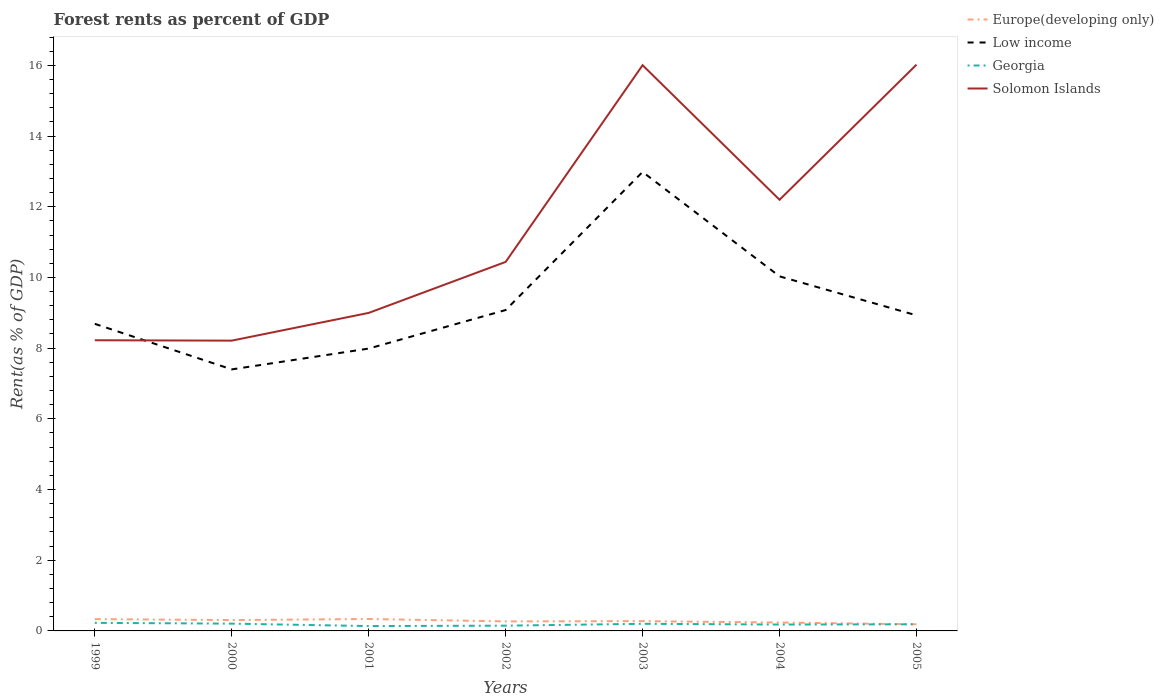How many different coloured lines are there?
Your answer should be very brief. 4. Is the number of lines equal to the number of legend labels?
Offer a terse response. Yes. Across all years, what is the maximum forest rent in Solomon Islands?
Keep it short and to the point. 8.21. What is the total forest rent in Low income in the graph?
Offer a terse response. 2.95. What is the difference between the highest and the second highest forest rent in Solomon Islands?
Offer a terse response. 7.81. How many lines are there?
Provide a succinct answer. 4. What is the difference between two consecutive major ticks on the Y-axis?
Provide a short and direct response. 2. Does the graph contain grids?
Give a very brief answer. No. Where does the legend appear in the graph?
Make the answer very short. Top right. How many legend labels are there?
Provide a succinct answer. 4. What is the title of the graph?
Provide a short and direct response. Forest rents as percent of GDP. What is the label or title of the Y-axis?
Your answer should be compact. Rent(as % of GDP). What is the Rent(as % of GDP) in Europe(developing only) in 1999?
Keep it short and to the point. 0.33. What is the Rent(as % of GDP) in Low income in 1999?
Provide a succinct answer. 8.69. What is the Rent(as % of GDP) in Georgia in 1999?
Your answer should be compact. 0.23. What is the Rent(as % of GDP) of Solomon Islands in 1999?
Give a very brief answer. 8.22. What is the Rent(as % of GDP) in Europe(developing only) in 2000?
Offer a very short reply. 0.31. What is the Rent(as % of GDP) in Low income in 2000?
Offer a terse response. 7.4. What is the Rent(as % of GDP) of Georgia in 2000?
Ensure brevity in your answer.  0.21. What is the Rent(as % of GDP) in Solomon Islands in 2000?
Keep it short and to the point. 8.21. What is the Rent(as % of GDP) in Europe(developing only) in 2001?
Keep it short and to the point. 0.34. What is the Rent(as % of GDP) of Low income in 2001?
Your answer should be compact. 7.99. What is the Rent(as % of GDP) in Georgia in 2001?
Make the answer very short. 0.14. What is the Rent(as % of GDP) of Solomon Islands in 2001?
Your answer should be compact. 9. What is the Rent(as % of GDP) of Europe(developing only) in 2002?
Provide a short and direct response. 0.27. What is the Rent(as % of GDP) of Low income in 2002?
Offer a terse response. 9.08. What is the Rent(as % of GDP) of Georgia in 2002?
Provide a short and direct response. 0.15. What is the Rent(as % of GDP) of Solomon Islands in 2002?
Your answer should be very brief. 10.44. What is the Rent(as % of GDP) in Europe(developing only) in 2003?
Give a very brief answer. 0.28. What is the Rent(as % of GDP) in Low income in 2003?
Offer a very short reply. 12.98. What is the Rent(as % of GDP) of Georgia in 2003?
Offer a very short reply. 0.2. What is the Rent(as % of GDP) of Solomon Islands in 2003?
Your response must be concise. 16. What is the Rent(as % of GDP) in Europe(developing only) in 2004?
Ensure brevity in your answer.  0.24. What is the Rent(as % of GDP) of Low income in 2004?
Keep it short and to the point. 10.03. What is the Rent(as % of GDP) of Georgia in 2004?
Your answer should be very brief. 0.18. What is the Rent(as % of GDP) in Solomon Islands in 2004?
Offer a terse response. 12.2. What is the Rent(as % of GDP) in Europe(developing only) in 2005?
Provide a succinct answer. 0.19. What is the Rent(as % of GDP) in Low income in 2005?
Provide a succinct answer. 8.93. What is the Rent(as % of GDP) of Georgia in 2005?
Your answer should be very brief. 0.19. What is the Rent(as % of GDP) in Solomon Islands in 2005?
Provide a short and direct response. 16.02. Across all years, what is the maximum Rent(as % of GDP) of Europe(developing only)?
Your response must be concise. 0.34. Across all years, what is the maximum Rent(as % of GDP) of Low income?
Give a very brief answer. 12.98. Across all years, what is the maximum Rent(as % of GDP) of Georgia?
Your response must be concise. 0.23. Across all years, what is the maximum Rent(as % of GDP) in Solomon Islands?
Your answer should be compact. 16.02. Across all years, what is the minimum Rent(as % of GDP) of Europe(developing only)?
Your answer should be very brief. 0.19. Across all years, what is the minimum Rent(as % of GDP) in Low income?
Provide a succinct answer. 7.4. Across all years, what is the minimum Rent(as % of GDP) in Georgia?
Offer a terse response. 0.14. Across all years, what is the minimum Rent(as % of GDP) in Solomon Islands?
Your answer should be compact. 8.21. What is the total Rent(as % of GDP) in Europe(developing only) in the graph?
Give a very brief answer. 1.95. What is the total Rent(as % of GDP) in Low income in the graph?
Your answer should be compact. 65.1. What is the total Rent(as % of GDP) in Georgia in the graph?
Ensure brevity in your answer.  1.29. What is the total Rent(as % of GDP) of Solomon Islands in the graph?
Provide a short and direct response. 80.09. What is the difference between the Rent(as % of GDP) in Europe(developing only) in 1999 and that in 2000?
Your response must be concise. 0.03. What is the difference between the Rent(as % of GDP) of Low income in 1999 and that in 2000?
Your answer should be very brief. 1.29. What is the difference between the Rent(as % of GDP) of Georgia in 1999 and that in 2000?
Ensure brevity in your answer.  0.02. What is the difference between the Rent(as % of GDP) in Solomon Islands in 1999 and that in 2000?
Your response must be concise. 0.01. What is the difference between the Rent(as % of GDP) of Europe(developing only) in 1999 and that in 2001?
Provide a succinct answer. -0. What is the difference between the Rent(as % of GDP) in Low income in 1999 and that in 2001?
Provide a short and direct response. 0.7. What is the difference between the Rent(as % of GDP) in Georgia in 1999 and that in 2001?
Ensure brevity in your answer.  0.09. What is the difference between the Rent(as % of GDP) in Solomon Islands in 1999 and that in 2001?
Provide a short and direct response. -0.77. What is the difference between the Rent(as % of GDP) of Europe(developing only) in 1999 and that in 2002?
Provide a succinct answer. 0.06. What is the difference between the Rent(as % of GDP) of Low income in 1999 and that in 2002?
Ensure brevity in your answer.  -0.39. What is the difference between the Rent(as % of GDP) of Georgia in 1999 and that in 2002?
Make the answer very short. 0.08. What is the difference between the Rent(as % of GDP) in Solomon Islands in 1999 and that in 2002?
Ensure brevity in your answer.  -2.22. What is the difference between the Rent(as % of GDP) of Europe(developing only) in 1999 and that in 2003?
Your response must be concise. 0.06. What is the difference between the Rent(as % of GDP) of Low income in 1999 and that in 2003?
Provide a succinct answer. -4.3. What is the difference between the Rent(as % of GDP) of Georgia in 1999 and that in 2003?
Offer a very short reply. 0.03. What is the difference between the Rent(as % of GDP) in Solomon Islands in 1999 and that in 2003?
Your answer should be very brief. -7.78. What is the difference between the Rent(as % of GDP) in Europe(developing only) in 1999 and that in 2004?
Make the answer very short. 0.1. What is the difference between the Rent(as % of GDP) in Low income in 1999 and that in 2004?
Offer a terse response. -1.34. What is the difference between the Rent(as % of GDP) of Georgia in 1999 and that in 2004?
Provide a short and direct response. 0.05. What is the difference between the Rent(as % of GDP) of Solomon Islands in 1999 and that in 2004?
Offer a terse response. -3.97. What is the difference between the Rent(as % of GDP) of Europe(developing only) in 1999 and that in 2005?
Your response must be concise. 0.15. What is the difference between the Rent(as % of GDP) in Low income in 1999 and that in 2005?
Give a very brief answer. -0.24. What is the difference between the Rent(as % of GDP) in Georgia in 1999 and that in 2005?
Offer a terse response. 0.04. What is the difference between the Rent(as % of GDP) of Solomon Islands in 1999 and that in 2005?
Offer a terse response. -7.8. What is the difference between the Rent(as % of GDP) of Europe(developing only) in 2000 and that in 2001?
Your answer should be compact. -0.03. What is the difference between the Rent(as % of GDP) of Low income in 2000 and that in 2001?
Your answer should be compact. -0.59. What is the difference between the Rent(as % of GDP) in Georgia in 2000 and that in 2001?
Offer a terse response. 0.07. What is the difference between the Rent(as % of GDP) in Solomon Islands in 2000 and that in 2001?
Keep it short and to the point. -0.78. What is the difference between the Rent(as % of GDP) of Europe(developing only) in 2000 and that in 2002?
Provide a succinct answer. 0.04. What is the difference between the Rent(as % of GDP) in Low income in 2000 and that in 2002?
Offer a very short reply. -1.68. What is the difference between the Rent(as % of GDP) of Georgia in 2000 and that in 2002?
Provide a short and direct response. 0.06. What is the difference between the Rent(as % of GDP) of Solomon Islands in 2000 and that in 2002?
Ensure brevity in your answer.  -2.23. What is the difference between the Rent(as % of GDP) of Europe(developing only) in 2000 and that in 2003?
Ensure brevity in your answer.  0.03. What is the difference between the Rent(as % of GDP) in Low income in 2000 and that in 2003?
Offer a terse response. -5.59. What is the difference between the Rent(as % of GDP) of Georgia in 2000 and that in 2003?
Provide a short and direct response. 0. What is the difference between the Rent(as % of GDP) of Solomon Islands in 2000 and that in 2003?
Your answer should be very brief. -7.79. What is the difference between the Rent(as % of GDP) in Europe(developing only) in 2000 and that in 2004?
Your answer should be very brief. 0.07. What is the difference between the Rent(as % of GDP) in Low income in 2000 and that in 2004?
Make the answer very short. -2.63. What is the difference between the Rent(as % of GDP) in Georgia in 2000 and that in 2004?
Your answer should be compact. 0.03. What is the difference between the Rent(as % of GDP) in Solomon Islands in 2000 and that in 2004?
Make the answer very short. -3.98. What is the difference between the Rent(as % of GDP) in Europe(developing only) in 2000 and that in 2005?
Your answer should be compact. 0.12. What is the difference between the Rent(as % of GDP) of Low income in 2000 and that in 2005?
Offer a terse response. -1.53. What is the difference between the Rent(as % of GDP) in Georgia in 2000 and that in 2005?
Offer a very short reply. 0.02. What is the difference between the Rent(as % of GDP) in Solomon Islands in 2000 and that in 2005?
Make the answer very short. -7.81. What is the difference between the Rent(as % of GDP) of Europe(developing only) in 2001 and that in 2002?
Ensure brevity in your answer.  0.07. What is the difference between the Rent(as % of GDP) of Low income in 2001 and that in 2002?
Your answer should be compact. -1.09. What is the difference between the Rent(as % of GDP) of Georgia in 2001 and that in 2002?
Give a very brief answer. -0.01. What is the difference between the Rent(as % of GDP) of Solomon Islands in 2001 and that in 2002?
Make the answer very short. -1.44. What is the difference between the Rent(as % of GDP) of Europe(developing only) in 2001 and that in 2003?
Ensure brevity in your answer.  0.06. What is the difference between the Rent(as % of GDP) of Low income in 2001 and that in 2003?
Offer a terse response. -5. What is the difference between the Rent(as % of GDP) of Georgia in 2001 and that in 2003?
Your response must be concise. -0.06. What is the difference between the Rent(as % of GDP) of Solomon Islands in 2001 and that in 2003?
Ensure brevity in your answer.  -7.01. What is the difference between the Rent(as % of GDP) in Europe(developing only) in 2001 and that in 2004?
Your response must be concise. 0.1. What is the difference between the Rent(as % of GDP) of Low income in 2001 and that in 2004?
Offer a very short reply. -2.04. What is the difference between the Rent(as % of GDP) in Georgia in 2001 and that in 2004?
Provide a short and direct response. -0.04. What is the difference between the Rent(as % of GDP) in Solomon Islands in 2001 and that in 2004?
Your answer should be very brief. -3.2. What is the difference between the Rent(as % of GDP) in Europe(developing only) in 2001 and that in 2005?
Offer a terse response. 0.15. What is the difference between the Rent(as % of GDP) in Low income in 2001 and that in 2005?
Make the answer very short. -0.94. What is the difference between the Rent(as % of GDP) of Georgia in 2001 and that in 2005?
Your response must be concise. -0.05. What is the difference between the Rent(as % of GDP) of Solomon Islands in 2001 and that in 2005?
Offer a very short reply. -7.02. What is the difference between the Rent(as % of GDP) of Europe(developing only) in 2002 and that in 2003?
Your answer should be compact. -0.01. What is the difference between the Rent(as % of GDP) in Low income in 2002 and that in 2003?
Provide a succinct answer. -3.91. What is the difference between the Rent(as % of GDP) in Georgia in 2002 and that in 2003?
Give a very brief answer. -0.05. What is the difference between the Rent(as % of GDP) in Solomon Islands in 2002 and that in 2003?
Your answer should be very brief. -5.56. What is the difference between the Rent(as % of GDP) of Europe(developing only) in 2002 and that in 2004?
Offer a terse response. 0.03. What is the difference between the Rent(as % of GDP) in Low income in 2002 and that in 2004?
Your answer should be compact. -0.95. What is the difference between the Rent(as % of GDP) in Georgia in 2002 and that in 2004?
Provide a short and direct response. -0.03. What is the difference between the Rent(as % of GDP) of Solomon Islands in 2002 and that in 2004?
Your response must be concise. -1.76. What is the difference between the Rent(as % of GDP) in Europe(developing only) in 2002 and that in 2005?
Your response must be concise. 0.08. What is the difference between the Rent(as % of GDP) in Low income in 2002 and that in 2005?
Provide a succinct answer. 0.15. What is the difference between the Rent(as % of GDP) of Georgia in 2002 and that in 2005?
Give a very brief answer. -0.04. What is the difference between the Rent(as % of GDP) of Solomon Islands in 2002 and that in 2005?
Your response must be concise. -5.58. What is the difference between the Rent(as % of GDP) in Europe(developing only) in 2003 and that in 2004?
Give a very brief answer. 0.04. What is the difference between the Rent(as % of GDP) of Low income in 2003 and that in 2004?
Your response must be concise. 2.95. What is the difference between the Rent(as % of GDP) in Georgia in 2003 and that in 2004?
Provide a succinct answer. 0.02. What is the difference between the Rent(as % of GDP) of Solomon Islands in 2003 and that in 2004?
Your answer should be compact. 3.81. What is the difference between the Rent(as % of GDP) in Europe(developing only) in 2003 and that in 2005?
Offer a very short reply. 0.09. What is the difference between the Rent(as % of GDP) in Low income in 2003 and that in 2005?
Provide a short and direct response. 4.06. What is the difference between the Rent(as % of GDP) in Georgia in 2003 and that in 2005?
Give a very brief answer. 0.01. What is the difference between the Rent(as % of GDP) of Solomon Islands in 2003 and that in 2005?
Make the answer very short. -0.02. What is the difference between the Rent(as % of GDP) of Europe(developing only) in 2004 and that in 2005?
Offer a terse response. 0.05. What is the difference between the Rent(as % of GDP) of Low income in 2004 and that in 2005?
Make the answer very short. 1.1. What is the difference between the Rent(as % of GDP) of Georgia in 2004 and that in 2005?
Provide a short and direct response. -0.01. What is the difference between the Rent(as % of GDP) in Solomon Islands in 2004 and that in 2005?
Make the answer very short. -3.82. What is the difference between the Rent(as % of GDP) of Europe(developing only) in 1999 and the Rent(as % of GDP) of Low income in 2000?
Keep it short and to the point. -7.07. What is the difference between the Rent(as % of GDP) in Europe(developing only) in 1999 and the Rent(as % of GDP) in Georgia in 2000?
Provide a succinct answer. 0.13. What is the difference between the Rent(as % of GDP) in Europe(developing only) in 1999 and the Rent(as % of GDP) in Solomon Islands in 2000?
Offer a terse response. -7.88. What is the difference between the Rent(as % of GDP) in Low income in 1999 and the Rent(as % of GDP) in Georgia in 2000?
Offer a terse response. 8.48. What is the difference between the Rent(as % of GDP) of Low income in 1999 and the Rent(as % of GDP) of Solomon Islands in 2000?
Offer a terse response. 0.48. What is the difference between the Rent(as % of GDP) of Georgia in 1999 and the Rent(as % of GDP) of Solomon Islands in 2000?
Provide a short and direct response. -7.98. What is the difference between the Rent(as % of GDP) in Europe(developing only) in 1999 and the Rent(as % of GDP) in Low income in 2001?
Offer a very short reply. -7.65. What is the difference between the Rent(as % of GDP) of Europe(developing only) in 1999 and the Rent(as % of GDP) of Georgia in 2001?
Offer a very short reply. 0.2. What is the difference between the Rent(as % of GDP) of Europe(developing only) in 1999 and the Rent(as % of GDP) of Solomon Islands in 2001?
Your answer should be very brief. -8.66. What is the difference between the Rent(as % of GDP) of Low income in 1999 and the Rent(as % of GDP) of Georgia in 2001?
Your answer should be compact. 8.55. What is the difference between the Rent(as % of GDP) of Low income in 1999 and the Rent(as % of GDP) of Solomon Islands in 2001?
Provide a succinct answer. -0.31. What is the difference between the Rent(as % of GDP) of Georgia in 1999 and the Rent(as % of GDP) of Solomon Islands in 2001?
Ensure brevity in your answer.  -8.77. What is the difference between the Rent(as % of GDP) in Europe(developing only) in 1999 and the Rent(as % of GDP) in Low income in 2002?
Offer a very short reply. -8.74. What is the difference between the Rent(as % of GDP) in Europe(developing only) in 1999 and the Rent(as % of GDP) in Georgia in 2002?
Your answer should be compact. 0.18. What is the difference between the Rent(as % of GDP) of Europe(developing only) in 1999 and the Rent(as % of GDP) of Solomon Islands in 2002?
Keep it short and to the point. -10.11. What is the difference between the Rent(as % of GDP) in Low income in 1999 and the Rent(as % of GDP) in Georgia in 2002?
Make the answer very short. 8.54. What is the difference between the Rent(as % of GDP) of Low income in 1999 and the Rent(as % of GDP) of Solomon Islands in 2002?
Provide a short and direct response. -1.75. What is the difference between the Rent(as % of GDP) in Georgia in 1999 and the Rent(as % of GDP) in Solomon Islands in 2002?
Offer a very short reply. -10.21. What is the difference between the Rent(as % of GDP) of Europe(developing only) in 1999 and the Rent(as % of GDP) of Low income in 2003?
Ensure brevity in your answer.  -12.65. What is the difference between the Rent(as % of GDP) of Europe(developing only) in 1999 and the Rent(as % of GDP) of Georgia in 2003?
Your response must be concise. 0.13. What is the difference between the Rent(as % of GDP) of Europe(developing only) in 1999 and the Rent(as % of GDP) of Solomon Islands in 2003?
Offer a terse response. -15.67. What is the difference between the Rent(as % of GDP) in Low income in 1999 and the Rent(as % of GDP) in Georgia in 2003?
Offer a very short reply. 8.49. What is the difference between the Rent(as % of GDP) in Low income in 1999 and the Rent(as % of GDP) in Solomon Islands in 2003?
Provide a succinct answer. -7.32. What is the difference between the Rent(as % of GDP) of Georgia in 1999 and the Rent(as % of GDP) of Solomon Islands in 2003?
Your response must be concise. -15.78. What is the difference between the Rent(as % of GDP) of Europe(developing only) in 1999 and the Rent(as % of GDP) of Low income in 2004?
Provide a short and direct response. -9.7. What is the difference between the Rent(as % of GDP) in Europe(developing only) in 1999 and the Rent(as % of GDP) in Georgia in 2004?
Your answer should be very brief. 0.15. What is the difference between the Rent(as % of GDP) of Europe(developing only) in 1999 and the Rent(as % of GDP) of Solomon Islands in 2004?
Keep it short and to the point. -11.86. What is the difference between the Rent(as % of GDP) in Low income in 1999 and the Rent(as % of GDP) in Georgia in 2004?
Offer a very short reply. 8.51. What is the difference between the Rent(as % of GDP) of Low income in 1999 and the Rent(as % of GDP) of Solomon Islands in 2004?
Offer a very short reply. -3.51. What is the difference between the Rent(as % of GDP) in Georgia in 1999 and the Rent(as % of GDP) in Solomon Islands in 2004?
Your answer should be very brief. -11.97. What is the difference between the Rent(as % of GDP) in Europe(developing only) in 1999 and the Rent(as % of GDP) in Low income in 2005?
Offer a terse response. -8.59. What is the difference between the Rent(as % of GDP) in Europe(developing only) in 1999 and the Rent(as % of GDP) in Georgia in 2005?
Provide a short and direct response. 0.15. What is the difference between the Rent(as % of GDP) in Europe(developing only) in 1999 and the Rent(as % of GDP) in Solomon Islands in 2005?
Your response must be concise. -15.69. What is the difference between the Rent(as % of GDP) in Low income in 1999 and the Rent(as % of GDP) in Georgia in 2005?
Your answer should be very brief. 8.5. What is the difference between the Rent(as % of GDP) of Low income in 1999 and the Rent(as % of GDP) of Solomon Islands in 2005?
Your answer should be very brief. -7.33. What is the difference between the Rent(as % of GDP) in Georgia in 1999 and the Rent(as % of GDP) in Solomon Islands in 2005?
Your answer should be compact. -15.79. What is the difference between the Rent(as % of GDP) of Europe(developing only) in 2000 and the Rent(as % of GDP) of Low income in 2001?
Your answer should be very brief. -7.68. What is the difference between the Rent(as % of GDP) of Europe(developing only) in 2000 and the Rent(as % of GDP) of Georgia in 2001?
Provide a short and direct response. 0.17. What is the difference between the Rent(as % of GDP) of Europe(developing only) in 2000 and the Rent(as % of GDP) of Solomon Islands in 2001?
Keep it short and to the point. -8.69. What is the difference between the Rent(as % of GDP) of Low income in 2000 and the Rent(as % of GDP) of Georgia in 2001?
Ensure brevity in your answer.  7.26. What is the difference between the Rent(as % of GDP) in Low income in 2000 and the Rent(as % of GDP) in Solomon Islands in 2001?
Your answer should be compact. -1.6. What is the difference between the Rent(as % of GDP) of Georgia in 2000 and the Rent(as % of GDP) of Solomon Islands in 2001?
Provide a short and direct response. -8.79. What is the difference between the Rent(as % of GDP) of Europe(developing only) in 2000 and the Rent(as % of GDP) of Low income in 2002?
Make the answer very short. -8.77. What is the difference between the Rent(as % of GDP) in Europe(developing only) in 2000 and the Rent(as % of GDP) in Georgia in 2002?
Your answer should be very brief. 0.16. What is the difference between the Rent(as % of GDP) in Europe(developing only) in 2000 and the Rent(as % of GDP) in Solomon Islands in 2002?
Keep it short and to the point. -10.13. What is the difference between the Rent(as % of GDP) in Low income in 2000 and the Rent(as % of GDP) in Georgia in 2002?
Make the answer very short. 7.25. What is the difference between the Rent(as % of GDP) in Low income in 2000 and the Rent(as % of GDP) in Solomon Islands in 2002?
Provide a succinct answer. -3.04. What is the difference between the Rent(as % of GDP) of Georgia in 2000 and the Rent(as % of GDP) of Solomon Islands in 2002?
Keep it short and to the point. -10.23. What is the difference between the Rent(as % of GDP) of Europe(developing only) in 2000 and the Rent(as % of GDP) of Low income in 2003?
Provide a succinct answer. -12.68. What is the difference between the Rent(as % of GDP) in Europe(developing only) in 2000 and the Rent(as % of GDP) in Georgia in 2003?
Your answer should be compact. 0.11. What is the difference between the Rent(as % of GDP) in Europe(developing only) in 2000 and the Rent(as % of GDP) in Solomon Islands in 2003?
Offer a very short reply. -15.7. What is the difference between the Rent(as % of GDP) in Low income in 2000 and the Rent(as % of GDP) in Georgia in 2003?
Ensure brevity in your answer.  7.2. What is the difference between the Rent(as % of GDP) of Low income in 2000 and the Rent(as % of GDP) of Solomon Islands in 2003?
Offer a very short reply. -8.61. What is the difference between the Rent(as % of GDP) in Georgia in 2000 and the Rent(as % of GDP) in Solomon Islands in 2003?
Offer a terse response. -15.8. What is the difference between the Rent(as % of GDP) in Europe(developing only) in 2000 and the Rent(as % of GDP) in Low income in 2004?
Offer a very short reply. -9.72. What is the difference between the Rent(as % of GDP) of Europe(developing only) in 2000 and the Rent(as % of GDP) of Georgia in 2004?
Provide a succinct answer. 0.13. What is the difference between the Rent(as % of GDP) in Europe(developing only) in 2000 and the Rent(as % of GDP) in Solomon Islands in 2004?
Make the answer very short. -11.89. What is the difference between the Rent(as % of GDP) of Low income in 2000 and the Rent(as % of GDP) of Georgia in 2004?
Keep it short and to the point. 7.22. What is the difference between the Rent(as % of GDP) of Low income in 2000 and the Rent(as % of GDP) of Solomon Islands in 2004?
Make the answer very short. -4.8. What is the difference between the Rent(as % of GDP) of Georgia in 2000 and the Rent(as % of GDP) of Solomon Islands in 2004?
Offer a terse response. -11.99. What is the difference between the Rent(as % of GDP) in Europe(developing only) in 2000 and the Rent(as % of GDP) in Low income in 2005?
Your answer should be very brief. -8.62. What is the difference between the Rent(as % of GDP) of Europe(developing only) in 2000 and the Rent(as % of GDP) of Georgia in 2005?
Provide a succinct answer. 0.12. What is the difference between the Rent(as % of GDP) of Europe(developing only) in 2000 and the Rent(as % of GDP) of Solomon Islands in 2005?
Your answer should be very brief. -15.71. What is the difference between the Rent(as % of GDP) in Low income in 2000 and the Rent(as % of GDP) in Georgia in 2005?
Ensure brevity in your answer.  7.21. What is the difference between the Rent(as % of GDP) of Low income in 2000 and the Rent(as % of GDP) of Solomon Islands in 2005?
Offer a very short reply. -8.62. What is the difference between the Rent(as % of GDP) in Georgia in 2000 and the Rent(as % of GDP) in Solomon Islands in 2005?
Provide a short and direct response. -15.81. What is the difference between the Rent(as % of GDP) of Europe(developing only) in 2001 and the Rent(as % of GDP) of Low income in 2002?
Give a very brief answer. -8.74. What is the difference between the Rent(as % of GDP) in Europe(developing only) in 2001 and the Rent(as % of GDP) in Georgia in 2002?
Ensure brevity in your answer.  0.19. What is the difference between the Rent(as % of GDP) of Europe(developing only) in 2001 and the Rent(as % of GDP) of Solomon Islands in 2002?
Your answer should be compact. -10.1. What is the difference between the Rent(as % of GDP) of Low income in 2001 and the Rent(as % of GDP) of Georgia in 2002?
Offer a terse response. 7.84. What is the difference between the Rent(as % of GDP) in Low income in 2001 and the Rent(as % of GDP) in Solomon Islands in 2002?
Offer a terse response. -2.45. What is the difference between the Rent(as % of GDP) in Georgia in 2001 and the Rent(as % of GDP) in Solomon Islands in 2002?
Keep it short and to the point. -10.3. What is the difference between the Rent(as % of GDP) of Europe(developing only) in 2001 and the Rent(as % of GDP) of Low income in 2003?
Provide a succinct answer. -12.65. What is the difference between the Rent(as % of GDP) of Europe(developing only) in 2001 and the Rent(as % of GDP) of Georgia in 2003?
Your answer should be very brief. 0.14. What is the difference between the Rent(as % of GDP) of Europe(developing only) in 2001 and the Rent(as % of GDP) of Solomon Islands in 2003?
Keep it short and to the point. -15.67. What is the difference between the Rent(as % of GDP) in Low income in 2001 and the Rent(as % of GDP) in Georgia in 2003?
Provide a succinct answer. 7.79. What is the difference between the Rent(as % of GDP) of Low income in 2001 and the Rent(as % of GDP) of Solomon Islands in 2003?
Ensure brevity in your answer.  -8.02. What is the difference between the Rent(as % of GDP) of Georgia in 2001 and the Rent(as % of GDP) of Solomon Islands in 2003?
Ensure brevity in your answer.  -15.87. What is the difference between the Rent(as % of GDP) of Europe(developing only) in 2001 and the Rent(as % of GDP) of Low income in 2004?
Your response must be concise. -9.69. What is the difference between the Rent(as % of GDP) of Europe(developing only) in 2001 and the Rent(as % of GDP) of Georgia in 2004?
Provide a succinct answer. 0.16. What is the difference between the Rent(as % of GDP) of Europe(developing only) in 2001 and the Rent(as % of GDP) of Solomon Islands in 2004?
Your answer should be compact. -11.86. What is the difference between the Rent(as % of GDP) of Low income in 2001 and the Rent(as % of GDP) of Georgia in 2004?
Offer a terse response. 7.81. What is the difference between the Rent(as % of GDP) in Low income in 2001 and the Rent(as % of GDP) in Solomon Islands in 2004?
Provide a succinct answer. -4.21. What is the difference between the Rent(as % of GDP) in Georgia in 2001 and the Rent(as % of GDP) in Solomon Islands in 2004?
Make the answer very short. -12.06. What is the difference between the Rent(as % of GDP) in Europe(developing only) in 2001 and the Rent(as % of GDP) in Low income in 2005?
Provide a short and direct response. -8.59. What is the difference between the Rent(as % of GDP) in Europe(developing only) in 2001 and the Rent(as % of GDP) in Georgia in 2005?
Your answer should be very brief. 0.15. What is the difference between the Rent(as % of GDP) of Europe(developing only) in 2001 and the Rent(as % of GDP) of Solomon Islands in 2005?
Your answer should be compact. -15.68. What is the difference between the Rent(as % of GDP) of Low income in 2001 and the Rent(as % of GDP) of Georgia in 2005?
Provide a short and direct response. 7.8. What is the difference between the Rent(as % of GDP) in Low income in 2001 and the Rent(as % of GDP) in Solomon Islands in 2005?
Offer a very short reply. -8.03. What is the difference between the Rent(as % of GDP) in Georgia in 2001 and the Rent(as % of GDP) in Solomon Islands in 2005?
Offer a terse response. -15.88. What is the difference between the Rent(as % of GDP) of Europe(developing only) in 2002 and the Rent(as % of GDP) of Low income in 2003?
Keep it short and to the point. -12.72. What is the difference between the Rent(as % of GDP) of Europe(developing only) in 2002 and the Rent(as % of GDP) of Georgia in 2003?
Ensure brevity in your answer.  0.07. What is the difference between the Rent(as % of GDP) of Europe(developing only) in 2002 and the Rent(as % of GDP) of Solomon Islands in 2003?
Provide a succinct answer. -15.73. What is the difference between the Rent(as % of GDP) of Low income in 2002 and the Rent(as % of GDP) of Georgia in 2003?
Your response must be concise. 8.88. What is the difference between the Rent(as % of GDP) in Low income in 2002 and the Rent(as % of GDP) in Solomon Islands in 2003?
Your response must be concise. -6.93. What is the difference between the Rent(as % of GDP) in Georgia in 2002 and the Rent(as % of GDP) in Solomon Islands in 2003?
Offer a very short reply. -15.86. What is the difference between the Rent(as % of GDP) in Europe(developing only) in 2002 and the Rent(as % of GDP) in Low income in 2004?
Your response must be concise. -9.76. What is the difference between the Rent(as % of GDP) of Europe(developing only) in 2002 and the Rent(as % of GDP) of Georgia in 2004?
Your answer should be compact. 0.09. What is the difference between the Rent(as % of GDP) of Europe(developing only) in 2002 and the Rent(as % of GDP) of Solomon Islands in 2004?
Your answer should be very brief. -11.93. What is the difference between the Rent(as % of GDP) in Low income in 2002 and the Rent(as % of GDP) in Georgia in 2004?
Your answer should be compact. 8.9. What is the difference between the Rent(as % of GDP) of Low income in 2002 and the Rent(as % of GDP) of Solomon Islands in 2004?
Offer a terse response. -3.12. What is the difference between the Rent(as % of GDP) in Georgia in 2002 and the Rent(as % of GDP) in Solomon Islands in 2004?
Give a very brief answer. -12.05. What is the difference between the Rent(as % of GDP) in Europe(developing only) in 2002 and the Rent(as % of GDP) in Low income in 2005?
Ensure brevity in your answer.  -8.66. What is the difference between the Rent(as % of GDP) in Europe(developing only) in 2002 and the Rent(as % of GDP) in Georgia in 2005?
Provide a succinct answer. 0.08. What is the difference between the Rent(as % of GDP) in Europe(developing only) in 2002 and the Rent(as % of GDP) in Solomon Islands in 2005?
Provide a succinct answer. -15.75. What is the difference between the Rent(as % of GDP) of Low income in 2002 and the Rent(as % of GDP) of Georgia in 2005?
Your response must be concise. 8.89. What is the difference between the Rent(as % of GDP) in Low income in 2002 and the Rent(as % of GDP) in Solomon Islands in 2005?
Offer a terse response. -6.94. What is the difference between the Rent(as % of GDP) in Georgia in 2002 and the Rent(as % of GDP) in Solomon Islands in 2005?
Make the answer very short. -15.87. What is the difference between the Rent(as % of GDP) in Europe(developing only) in 2003 and the Rent(as % of GDP) in Low income in 2004?
Ensure brevity in your answer.  -9.75. What is the difference between the Rent(as % of GDP) of Europe(developing only) in 2003 and the Rent(as % of GDP) of Georgia in 2004?
Make the answer very short. 0.1. What is the difference between the Rent(as % of GDP) of Europe(developing only) in 2003 and the Rent(as % of GDP) of Solomon Islands in 2004?
Provide a succinct answer. -11.92. What is the difference between the Rent(as % of GDP) in Low income in 2003 and the Rent(as % of GDP) in Georgia in 2004?
Provide a short and direct response. 12.8. What is the difference between the Rent(as % of GDP) of Low income in 2003 and the Rent(as % of GDP) of Solomon Islands in 2004?
Ensure brevity in your answer.  0.79. What is the difference between the Rent(as % of GDP) in Georgia in 2003 and the Rent(as % of GDP) in Solomon Islands in 2004?
Ensure brevity in your answer.  -12. What is the difference between the Rent(as % of GDP) in Europe(developing only) in 2003 and the Rent(as % of GDP) in Low income in 2005?
Your answer should be very brief. -8.65. What is the difference between the Rent(as % of GDP) in Europe(developing only) in 2003 and the Rent(as % of GDP) in Georgia in 2005?
Keep it short and to the point. 0.09. What is the difference between the Rent(as % of GDP) of Europe(developing only) in 2003 and the Rent(as % of GDP) of Solomon Islands in 2005?
Offer a very short reply. -15.74. What is the difference between the Rent(as % of GDP) in Low income in 2003 and the Rent(as % of GDP) in Georgia in 2005?
Offer a terse response. 12.8. What is the difference between the Rent(as % of GDP) of Low income in 2003 and the Rent(as % of GDP) of Solomon Islands in 2005?
Your answer should be compact. -3.04. What is the difference between the Rent(as % of GDP) of Georgia in 2003 and the Rent(as % of GDP) of Solomon Islands in 2005?
Keep it short and to the point. -15.82. What is the difference between the Rent(as % of GDP) in Europe(developing only) in 2004 and the Rent(as % of GDP) in Low income in 2005?
Provide a short and direct response. -8.69. What is the difference between the Rent(as % of GDP) of Europe(developing only) in 2004 and the Rent(as % of GDP) of Georgia in 2005?
Your response must be concise. 0.05. What is the difference between the Rent(as % of GDP) in Europe(developing only) in 2004 and the Rent(as % of GDP) in Solomon Islands in 2005?
Your response must be concise. -15.78. What is the difference between the Rent(as % of GDP) in Low income in 2004 and the Rent(as % of GDP) in Georgia in 2005?
Keep it short and to the point. 9.84. What is the difference between the Rent(as % of GDP) in Low income in 2004 and the Rent(as % of GDP) in Solomon Islands in 2005?
Keep it short and to the point. -5.99. What is the difference between the Rent(as % of GDP) of Georgia in 2004 and the Rent(as % of GDP) of Solomon Islands in 2005?
Keep it short and to the point. -15.84. What is the average Rent(as % of GDP) of Europe(developing only) per year?
Make the answer very short. 0.28. What is the average Rent(as % of GDP) in Low income per year?
Provide a succinct answer. 9.3. What is the average Rent(as % of GDP) of Georgia per year?
Your response must be concise. 0.18. What is the average Rent(as % of GDP) in Solomon Islands per year?
Make the answer very short. 11.44. In the year 1999, what is the difference between the Rent(as % of GDP) in Europe(developing only) and Rent(as % of GDP) in Low income?
Your response must be concise. -8.35. In the year 1999, what is the difference between the Rent(as % of GDP) in Europe(developing only) and Rent(as % of GDP) in Georgia?
Your answer should be very brief. 0.11. In the year 1999, what is the difference between the Rent(as % of GDP) of Europe(developing only) and Rent(as % of GDP) of Solomon Islands?
Keep it short and to the point. -7.89. In the year 1999, what is the difference between the Rent(as % of GDP) of Low income and Rent(as % of GDP) of Georgia?
Your answer should be compact. 8.46. In the year 1999, what is the difference between the Rent(as % of GDP) of Low income and Rent(as % of GDP) of Solomon Islands?
Your answer should be very brief. 0.46. In the year 1999, what is the difference between the Rent(as % of GDP) in Georgia and Rent(as % of GDP) in Solomon Islands?
Offer a very short reply. -8. In the year 2000, what is the difference between the Rent(as % of GDP) of Europe(developing only) and Rent(as % of GDP) of Low income?
Offer a very short reply. -7.09. In the year 2000, what is the difference between the Rent(as % of GDP) in Europe(developing only) and Rent(as % of GDP) in Georgia?
Provide a short and direct response. 0.1. In the year 2000, what is the difference between the Rent(as % of GDP) of Europe(developing only) and Rent(as % of GDP) of Solomon Islands?
Provide a succinct answer. -7.91. In the year 2000, what is the difference between the Rent(as % of GDP) in Low income and Rent(as % of GDP) in Georgia?
Your answer should be very brief. 7.19. In the year 2000, what is the difference between the Rent(as % of GDP) in Low income and Rent(as % of GDP) in Solomon Islands?
Your answer should be very brief. -0.81. In the year 2000, what is the difference between the Rent(as % of GDP) in Georgia and Rent(as % of GDP) in Solomon Islands?
Your answer should be very brief. -8.01. In the year 2001, what is the difference between the Rent(as % of GDP) in Europe(developing only) and Rent(as % of GDP) in Low income?
Your answer should be compact. -7.65. In the year 2001, what is the difference between the Rent(as % of GDP) in Europe(developing only) and Rent(as % of GDP) in Georgia?
Give a very brief answer. 0.2. In the year 2001, what is the difference between the Rent(as % of GDP) in Europe(developing only) and Rent(as % of GDP) in Solomon Islands?
Your response must be concise. -8.66. In the year 2001, what is the difference between the Rent(as % of GDP) of Low income and Rent(as % of GDP) of Georgia?
Offer a very short reply. 7.85. In the year 2001, what is the difference between the Rent(as % of GDP) of Low income and Rent(as % of GDP) of Solomon Islands?
Give a very brief answer. -1.01. In the year 2001, what is the difference between the Rent(as % of GDP) of Georgia and Rent(as % of GDP) of Solomon Islands?
Provide a succinct answer. -8.86. In the year 2002, what is the difference between the Rent(as % of GDP) in Europe(developing only) and Rent(as % of GDP) in Low income?
Make the answer very short. -8.81. In the year 2002, what is the difference between the Rent(as % of GDP) of Europe(developing only) and Rent(as % of GDP) of Georgia?
Your response must be concise. 0.12. In the year 2002, what is the difference between the Rent(as % of GDP) in Europe(developing only) and Rent(as % of GDP) in Solomon Islands?
Offer a terse response. -10.17. In the year 2002, what is the difference between the Rent(as % of GDP) of Low income and Rent(as % of GDP) of Georgia?
Make the answer very short. 8.93. In the year 2002, what is the difference between the Rent(as % of GDP) in Low income and Rent(as % of GDP) in Solomon Islands?
Your answer should be compact. -1.36. In the year 2002, what is the difference between the Rent(as % of GDP) of Georgia and Rent(as % of GDP) of Solomon Islands?
Ensure brevity in your answer.  -10.29. In the year 2003, what is the difference between the Rent(as % of GDP) of Europe(developing only) and Rent(as % of GDP) of Low income?
Offer a very short reply. -12.71. In the year 2003, what is the difference between the Rent(as % of GDP) of Europe(developing only) and Rent(as % of GDP) of Georgia?
Keep it short and to the point. 0.08. In the year 2003, what is the difference between the Rent(as % of GDP) of Europe(developing only) and Rent(as % of GDP) of Solomon Islands?
Provide a succinct answer. -15.73. In the year 2003, what is the difference between the Rent(as % of GDP) in Low income and Rent(as % of GDP) in Georgia?
Your answer should be compact. 12.78. In the year 2003, what is the difference between the Rent(as % of GDP) of Low income and Rent(as % of GDP) of Solomon Islands?
Your answer should be compact. -3.02. In the year 2003, what is the difference between the Rent(as % of GDP) in Georgia and Rent(as % of GDP) in Solomon Islands?
Your answer should be compact. -15.8. In the year 2004, what is the difference between the Rent(as % of GDP) in Europe(developing only) and Rent(as % of GDP) in Low income?
Keep it short and to the point. -9.79. In the year 2004, what is the difference between the Rent(as % of GDP) of Europe(developing only) and Rent(as % of GDP) of Georgia?
Make the answer very short. 0.06. In the year 2004, what is the difference between the Rent(as % of GDP) in Europe(developing only) and Rent(as % of GDP) in Solomon Islands?
Keep it short and to the point. -11.96. In the year 2004, what is the difference between the Rent(as % of GDP) of Low income and Rent(as % of GDP) of Georgia?
Make the answer very short. 9.85. In the year 2004, what is the difference between the Rent(as % of GDP) in Low income and Rent(as % of GDP) in Solomon Islands?
Provide a short and direct response. -2.17. In the year 2004, what is the difference between the Rent(as % of GDP) of Georgia and Rent(as % of GDP) of Solomon Islands?
Keep it short and to the point. -12.02. In the year 2005, what is the difference between the Rent(as % of GDP) in Europe(developing only) and Rent(as % of GDP) in Low income?
Keep it short and to the point. -8.74. In the year 2005, what is the difference between the Rent(as % of GDP) of Europe(developing only) and Rent(as % of GDP) of Georgia?
Ensure brevity in your answer.  -0. In the year 2005, what is the difference between the Rent(as % of GDP) in Europe(developing only) and Rent(as % of GDP) in Solomon Islands?
Your answer should be very brief. -15.83. In the year 2005, what is the difference between the Rent(as % of GDP) in Low income and Rent(as % of GDP) in Georgia?
Offer a terse response. 8.74. In the year 2005, what is the difference between the Rent(as % of GDP) in Low income and Rent(as % of GDP) in Solomon Islands?
Provide a short and direct response. -7.09. In the year 2005, what is the difference between the Rent(as % of GDP) in Georgia and Rent(as % of GDP) in Solomon Islands?
Your response must be concise. -15.83. What is the ratio of the Rent(as % of GDP) of Europe(developing only) in 1999 to that in 2000?
Your response must be concise. 1.09. What is the ratio of the Rent(as % of GDP) in Low income in 1999 to that in 2000?
Give a very brief answer. 1.17. What is the ratio of the Rent(as % of GDP) of Georgia in 1999 to that in 2000?
Make the answer very short. 1.11. What is the ratio of the Rent(as % of GDP) in Solomon Islands in 1999 to that in 2000?
Offer a terse response. 1. What is the ratio of the Rent(as % of GDP) of Low income in 1999 to that in 2001?
Offer a very short reply. 1.09. What is the ratio of the Rent(as % of GDP) in Georgia in 1999 to that in 2001?
Make the answer very short. 1.66. What is the ratio of the Rent(as % of GDP) in Solomon Islands in 1999 to that in 2001?
Your answer should be compact. 0.91. What is the ratio of the Rent(as % of GDP) of Europe(developing only) in 1999 to that in 2002?
Your response must be concise. 1.24. What is the ratio of the Rent(as % of GDP) of Low income in 1999 to that in 2002?
Provide a succinct answer. 0.96. What is the ratio of the Rent(as % of GDP) in Georgia in 1999 to that in 2002?
Your answer should be compact. 1.53. What is the ratio of the Rent(as % of GDP) in Solomon Islands in 1999 to that in 2002?
Your answer should be compact. 0.79. What is the ratio of the Rent(as % of GDP) in Europe(developing only) in 1999 to that in 2003?
Offer a terse response. 1.2. What is the ratio of the Rent(as % of GDP) in Low income in 1999 to that in 2003?
Provide a short and direct response. 0.67. What is the ratio of the Rent(as % of GDP) in Georgia in 1999 to that in 2003?
Provide a short and direct response. 1.13. What is the ratio of the Rent(as % of GDP) of Solomon Islands in 1999 to that in 2003?
Give a very brief answer. 0.51. What is the ratio of the Rent(as % of GDP) of Europe(developing only) in 1999 to that in 2004?
Provide a short and direct response. 1.4. What is the ratio of the Rent(as % of GDP) in Low income in 1999 to that in 2004?
Your answer should be very brief. 0.87. What is the ratio of the Rent(as % of GDP) of Georgia in 1999 to that in 2004?
Keep it short and to the point. 1.26. What is the ratio of the Rent(as % of GDP) in Solomon Islands in 1999 to that in 2004?
Offer a very short reply. 0.67. What is the ratio of the Rent(as % of GDP) of Europe(developing only) in 1999 to that in 2005?
Keep it short and to the point. 1.78. What is the ratio of the Rent(as % of GDP) in Low income in 1999 to that in 2005?
Keep it short and to the point. 0.97. What is the ratio of the Rent(as % of GDP) in Georgia in 1999 to that in 2005?
Offer a terse response. 1.22. What is the ratio of the Rent(as % of GDP) of Solomon Islands in 1999 to that in 2005?
Ensure brevity in your answer.  0.51. What is the ratio of the Rent(as % of GDP) of Europe(developing only) in 2000 to that in 2001?
Your response must be concise. 0.91. What is the ratio of the Rent(as % of GDP) in Low income in 2000 to that in 2001?
Your answer should be compact. 0.93. What is the ratio of the Rent(as % of GDP) of Georgia in 2000 to that in 2001?
Your response must be concise. 1.5. What is the ratio of the Rent(as % of GDP) of Solomon Islands in 2000 to that in 2001?
Provide a succinct answer. 0.91. What is the ratio of the Rent(as % of GDP) in Europe(developing only) in 2000 to that in 2002?
Make the answer very short. 1.14. What is the ratio of the Rent(as % of GDP) in Low income in 2000 to that in 2002?
Give a very brief answer. 0.81. What is the ratio of the Rent(as % of GDP) in Georgia in 2000 to that in 2002?
Your response must be concise. 1.38. What is the ratio of the Rent(as % of GDP) of Solomon Islands in 2000 to that in 2002?
Provide a succinct answer. 0.79. What is the ratio of the Rent(as % of GDP) in Europe(developing only) in 2000 to that in 2003?
Make the answer very short. 1.11. What is the ratio of the Rent(as % of GDP) in Low income in 2000 to that in 2003?
Offer a very short reply. 0.57. What is the ratio of the Rent(as % of GDP) in Solomon Islands in 2000 to that in 2003?
Ensure brevity in your answer.  0.51. What is the ratio of the Rent(as % of GDP) of Europe(developing only) in 2000 to that in 2004?
Your response must be concise. 1.29. What is the ratio of the Rent(as % of GDP) of Low income in 2000 to that in 2004?
Keep it short and to the point. 0.74. What is the ratio of the Rent(as % of GDP) in Georgia in 2000 to that in 2004?
Make the answer very short. 1.14. What is the ratio of the Rent(as % of GDP) of Solomon Islands in 2000 to that in 2004?
Provide a short and direct response. 0.67. What is the ratio of the Rent(as % of GDP) of Europe(developing only) in 2000 to that in 2005?
Provide a succinct answer. 1.64. What is the ratio of the Rent(as % of GDP) in Low income in 2000 to that in 2005?
Provide a succinct answer. 0.83. What is the ratio of the Rent(as % of GDP) in Georgia in 2000 to that in 2005?
Your answer should be very brief. 1.1. What is the ratio of the Rent(as % of GDP) of Solomon Islands in 2000 to that in 2005?
Give a very brief answer. 0.51. What is the ratio of the Rent(as % of GDP) of Europe(developing only) in 2001 to that in 2002?
Offer a terse response. 1.25. What is the ratio of the Rent(as % of GDP) in Low income in 2001 to that in 2002?
Make the answer very short. 0.88. What is the ratio of the Rent(as % of GDP) in Georgia in 2001 to that in 2002?
Your answer should be very brief. 0.92. What is the ratio of the Rent(as % of GDP) of Solomon Islands in 2001 to that in 2002?
Your answer should be compact. 0.86. What is the ratio of the Rent(as % of GDP) in Europe(developing only) in 2001 to that in 2003?
Your response must be concise. 1.22. What is the ratio of the Rent(as % of GDP) in Low income in 2001 to that in 2003?
Keep it short and to the point. 0.62. What is the ratio of the Rent(as % of GDP) in Georgia in 2001 to that in 2003?
Your response must be concise. 0.68. What is the ratio of the Rent(as % of GDP) in Solomon Islands in 2001 to that in 2003?
Offer a terse response. 0.56. What is the ratio of the Rent(as % of GDP) in Europe(developing only) in 2001 to that in 2004?
Your answer should be compact. 1.42. What is the ratio of the Rent(as % of GDP) of Low income in 2001 to that in 2004?
Your response must be concise. 0.8. What is the ratio of the Rent(as % of GDP) of Georgia in 2001 to that in 2004?
Provide a short and direct response. 0.76. What is the ratio of the Rent(as % of GDP) in Solomon Islands in 2001 to that in 2004?
Offer a very short reply. 0.74. What is the ratio of the Rent(as % of GDP) of Europe(developing only) in 2001 to that in 2005?
Your answer should be very brief. 1.8. What is the ratio of the Rent(as % of GDP) in Low income in 2001 to that in 2005?
Ensure brevity in your answer.  0.89. What is the ratio of the Rent(as % of GDP) in Georgia in 2001 to that in 2005?
Provide a succinct answer. 0.73. What is the ratio of the Rent(as % of GDP) of Solomon Islands in 2001 to that in 2005?
Provide a short and direct response. 0.56. What is the ratio of the Rent(as % of GDP) in Europe(developing only) in 2002 to that in 2003?
Provide a short and direct response. 0.97. What is the ratio of the Rent(as % of GDP) in Low income in 2002 to that in 2003?
Your response must be concise. 0.7. What is the ratio of the Rent(as % of GDP) of Georgia in 2002 to that in 2003?
Ensure brevity in your answer.  0.74. What is the ratio of the Rent(as % of GDP) in Solomon Islands in 2002 to that in 2003?
Provide a succinct answer. 0.65. What is the ratio of the Rent(as % of GDP) of Europe(developing only) in 2002 to that in 2004?
Your answer should be compact. 1.13. What is the ratio of the Rent(as % of GDP) of Low income in 2002 to that in 2004?
Your answer should be compact. 0.91. What is the ratio of the Rent(as % of GDP) in Georgia in 2002 to that in 2004?
Give a very brief answer. 0.82. What is the ratio of the Rent(as % of GDP) in Solomon Islands in 2002 to that in 2004?
Ensure brevity in your answer.  0.86. What is the ratio of the Rent(as % of GDP) of Europe(developing only) in 2002 to that in 2005?
Offer a terse response. 1.44. What is the ratio of the Rent(as % of GDP) in Low income in 2002 to that in 2005?
Keep it short and to the point. 1.02. What is the ratio of the Rent(as % of GDP) in Georgia in 2002 to that in 2005?
Give a very brief answer. 0.79. What is the ratio of the Rent(as % of GDP) of Solomon Islands in 2002 to that in 2005?
Offer a terse response. 0.65. What is the ratio of the Rent(as % of GDP) in Europe(developing only) in 2003 to that in 2004?
Provide a short and direct response. 1.16. What is the ratio of the Rent(as % of GDP) of Low income in 2003 to that in 2004?
Make the answer very short. 1.29. What is the ratio of the Rent(as % of GDP) in Georgia in 2003 to that in 2004?
Your response must be concise. 1.11. What is the ratio of the Rent(as % of GDP) in Solomon Islands in 2003 to that in 2004?
Make the answer very short. 1.31. What is the ratio of the Rent(as % of GDP) in Europe(developing only) in 2003 to that in 2005?
Ensure brevity in your answer.  1.48. What is the ratio of the Rent(as % of GDP) in Low income in 2003 to that in 2005?
Keep it short and to the point. 1.45. What is the ratio of the Rent(as % of GDP) in Georgia in 2003 to that in 2005?
Provide a short and direct response. 1.07. What is the ratio of the Rent(as % of GDP) of Solomon Islands in 2003 to that in 2005?
Offer a very short reply. 1. What is the ratio of the Rent(as % of GDP) of Europe(developing only) in 2004 to that in 2005?
Your answer should be compact. 1.27. What is the ratio of the Rent(as % of GDP) in Low income in 2004 to that in 2005?
Provide a short and direct response. 1.12. What is the ratio of the Rent(as % of GDP) in Georgia in 2004 to that in 2005?
Your response must be concise. 0.96. What is the ratio of the Rent(as % of GDP) of Solomon Islands in 2004 to that in 2005?
Make the answer very short. 0.76. What is the difference between the highest and the second highest Rent(as % of GDP) in Europe(developing only)?
Offer a terse response. 0. What is the difference between the highest and the second highest Rent(as % of GDP) in Low income?
Provide a succinct answer. 2.95. What is the difference between the highest and the second highest Rent(as % of GDP) of Georgia?
Your answer should be very brief. 0.02. What is the difference between the highest and the second highest Rent(as % of GDP) in Solomon Islands?
Keep it short and to the point. 0.02. What is the difference between the highest and the lowest Rent(as % of GDP) in Europe(developing only)?
Your response must be concise. 0.15. What is the difference between the highest and the lowest Rent(as % of GDP) of Low income?
Provide a succinct answer. 5.59. What is the difference between the highest and the lowest Rent(as % of GDP) in Georgia?
Provide a succinct answer. 0.09. What is the difference between the highest and the lowest Rent(as % of GDP) in Solomon Islands?
Make the answer very short. 7.81. 